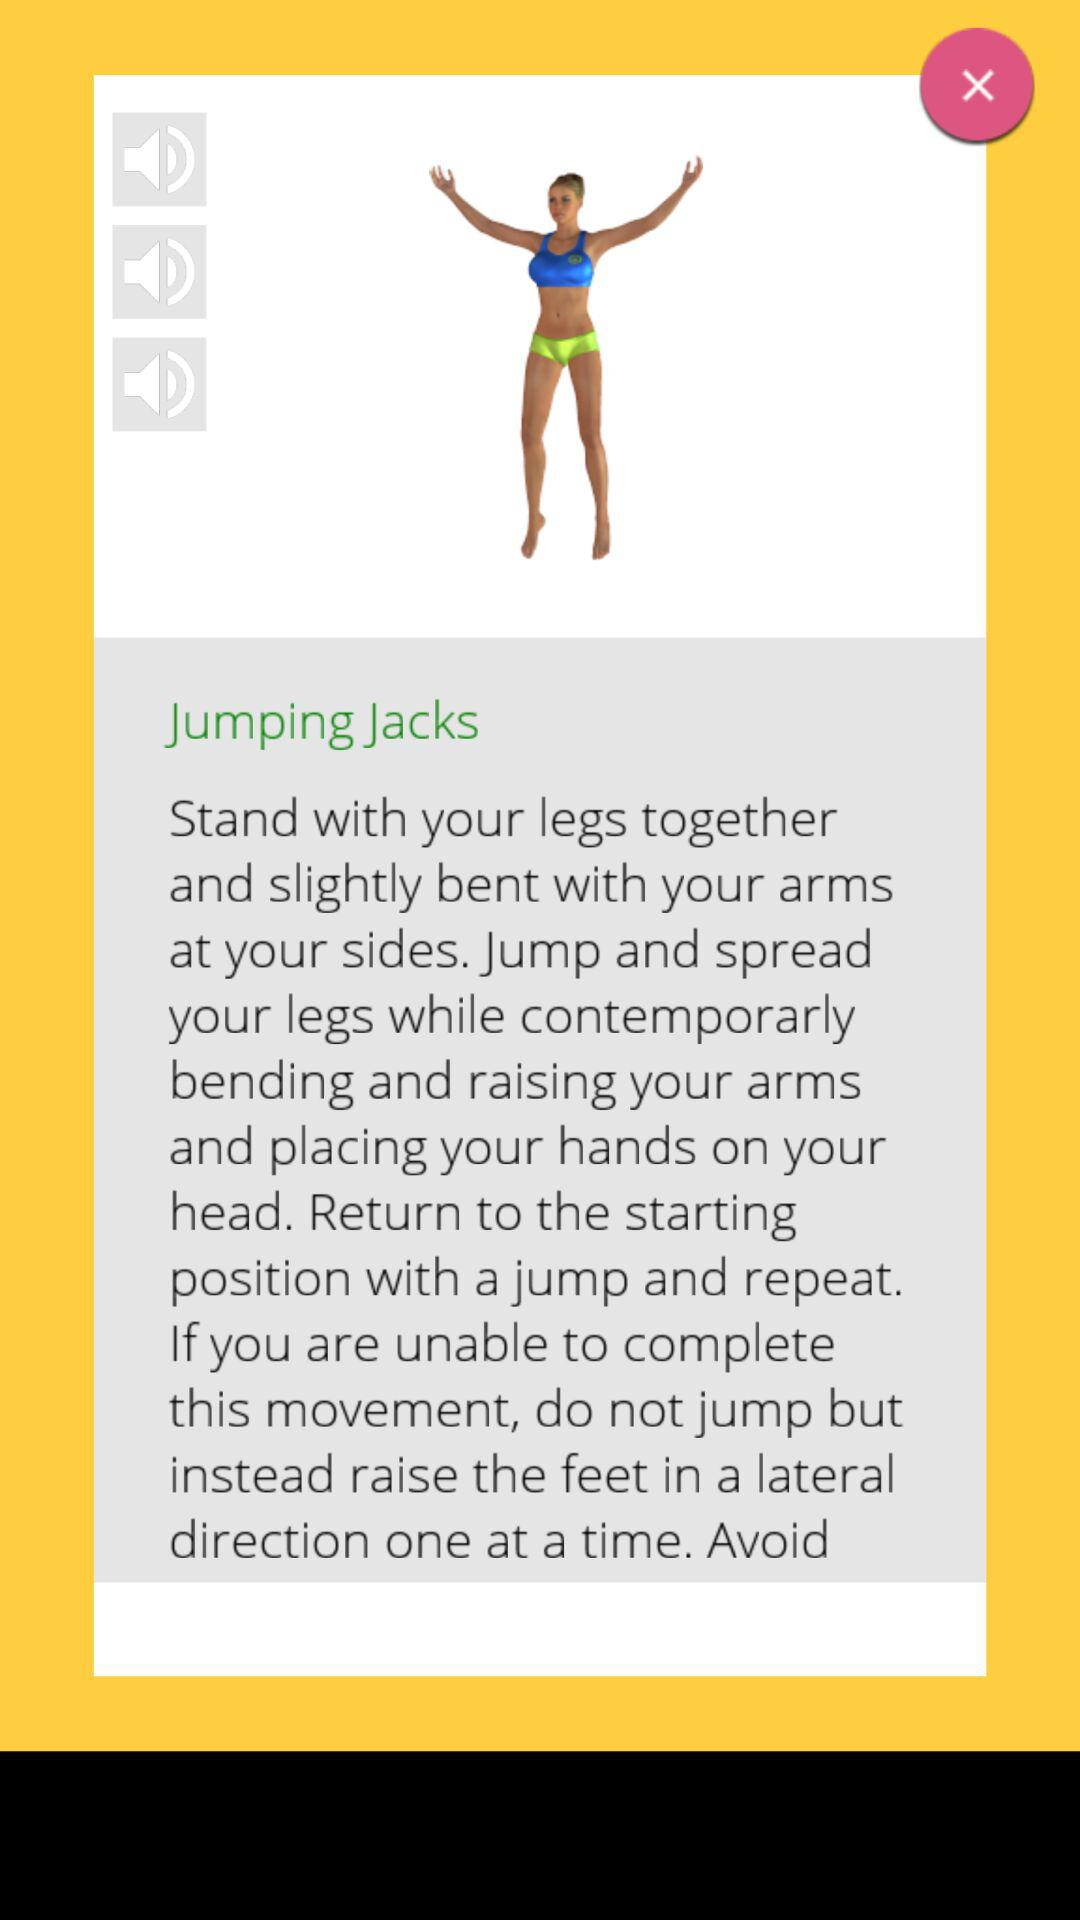How many volume indicators are there?
Answer the question using a single word or phrase. 3 